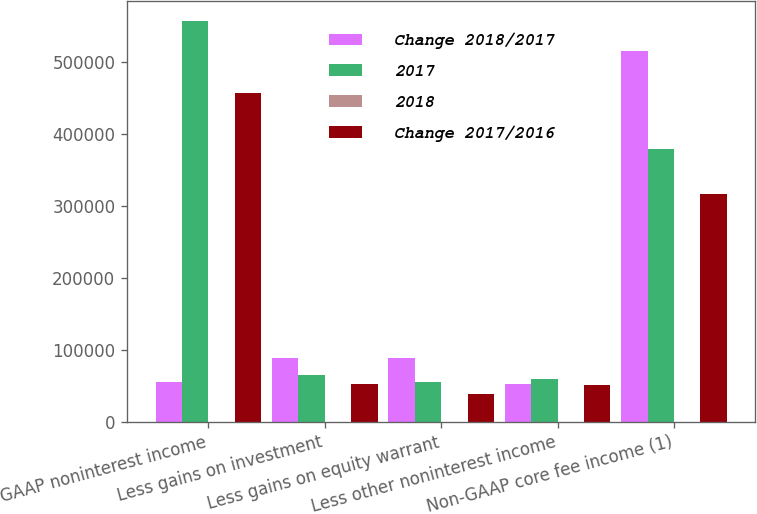<chart> <loc_0><loc_0><loc_500><loc_500><stacked_bar_chart><ecel><fcel>GAAP noninterest income<fcel>Less gains on investment<fcel>Less gains on equity warrant<fcel>Less other noninterest income<fcel>Non-GAAP core fee income (1)<nl><fcel>Change 2018/2017<fcel>54555<fcel>88094<fcel>89142<fcel>51858<fcel>515890<nl><fcel>2017<fcel>557231<fcel>64603<fcel>54555<fcel>59110<fcel>378963<nl><fcel>2018<fcel>33.7<fcel>36.4<fcel>63.4<fcel>12.3<fcel>36.1<nl><fcel>Change 2017/2016<fcel>456552<fcel>51740<fcel>37892<fcel>50750<fcel>316170<nl></chart> 